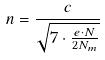<formula> <loc_0><loc_0><loc_500><loc_500>n = \frac { c } { \sqrt { 7 \cdot \frac { e \cdot N } { 2 N _ { m } } } }</formula> 